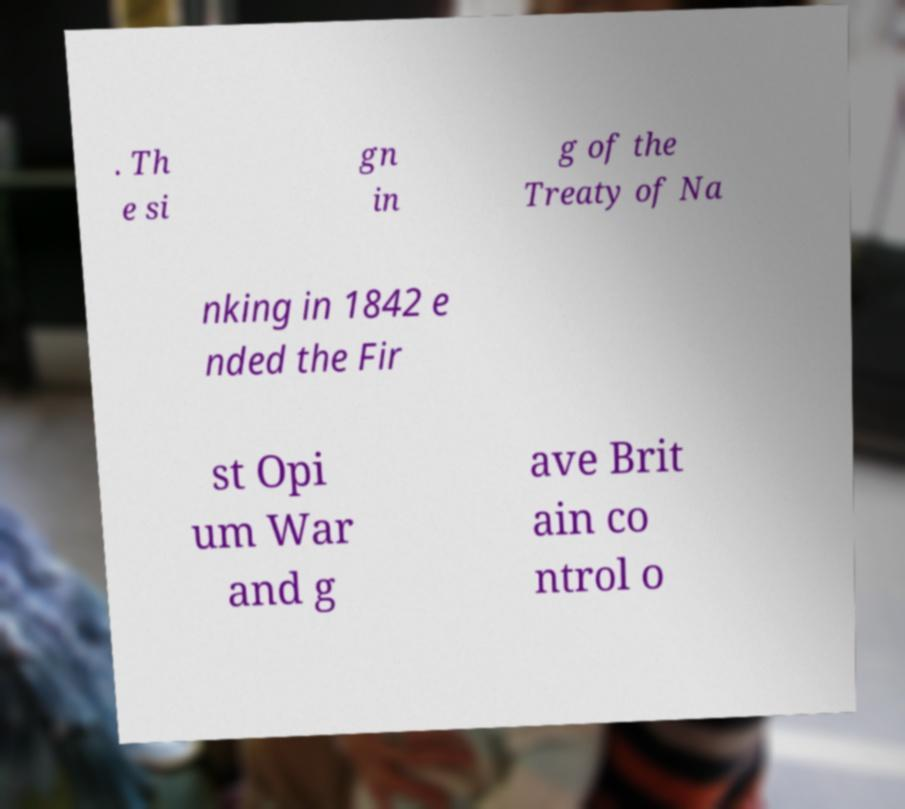Could you assist in decoding the text presented in this image and type it out clearly? . Th e si gn in g of the Treaty of Na nking in 1842 e nded the Fir st Opi um War and g ave Brit ain co ntrol o 